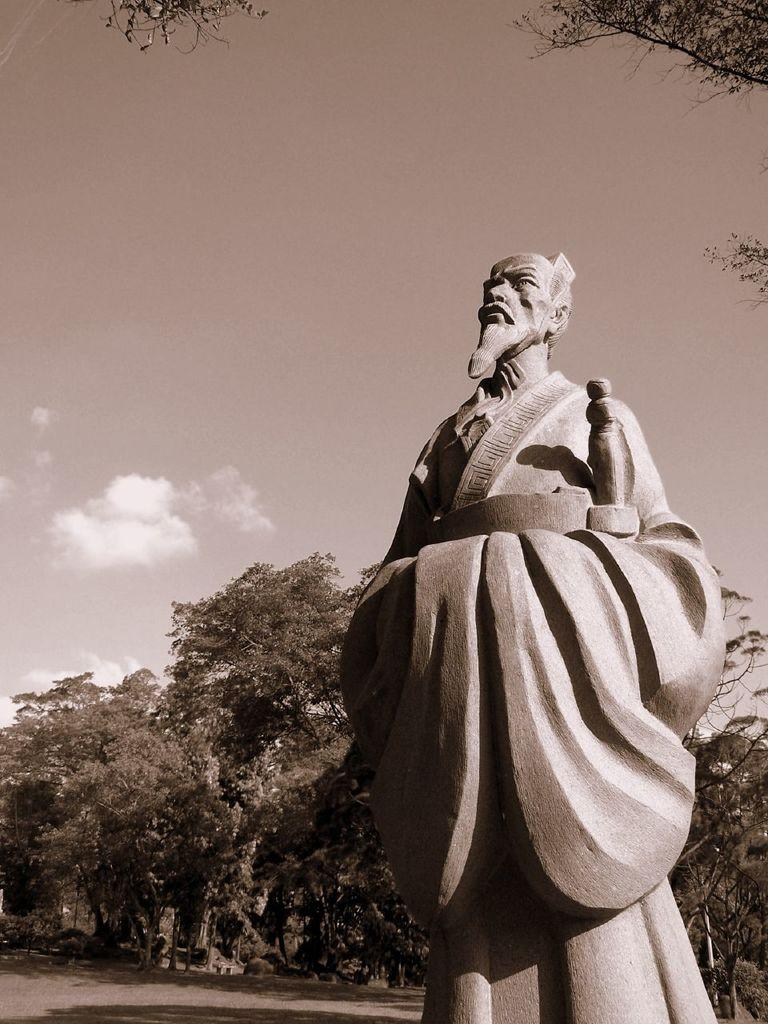What is the main subject in the foreground of the image? There is a statue in the foreground of the image. What can be seen at the top of the image? Tree branches are visible at the top of the image. What is visible in the background of the image? There are trees in the background of the image. What is the condition of the sky in the image? The sky is clear, and it is sunny. What type of jam is being spread on the statue in the image? There is no jam present in the image, and the statue is not being used for spreading jam. What amusement park can be seen in the background of the image? There is no amusement park visible in the image; it features a statue, tree branches, trees, and a clear, sunny sky. 